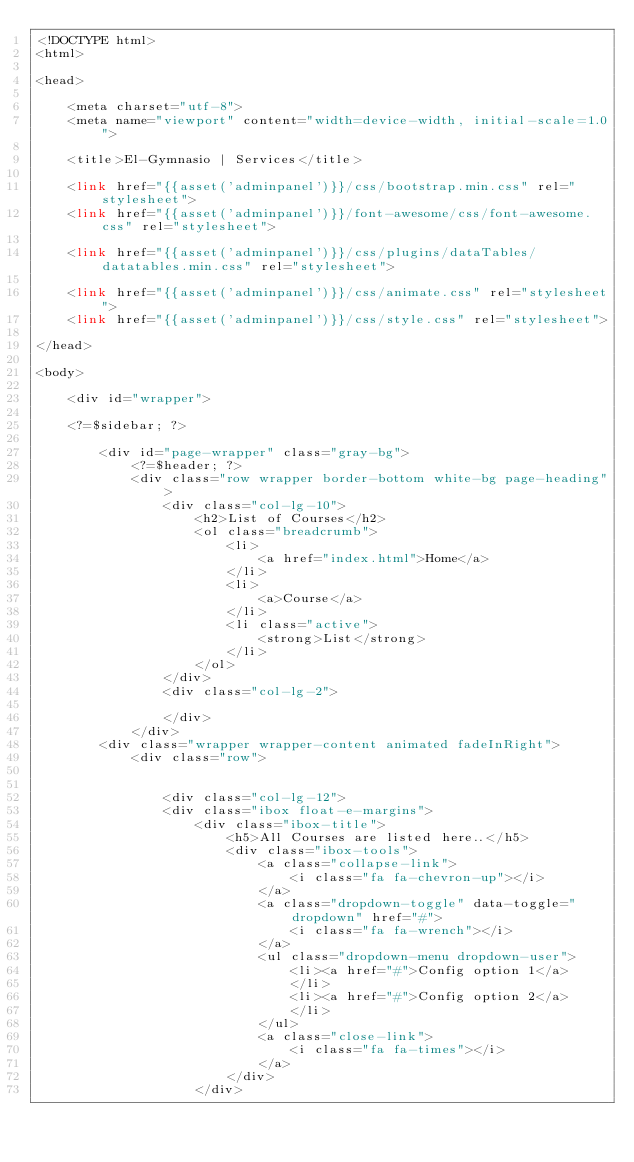Convert code to text. <code><loc_0><loc_0><loc_500><loc_500><_PHP_><!DOCTYPE html>
<html>

<head>

    <meta charset="utf-8">
    <meta name="viewport" content="width=device-width, initial-scale=1.0">

    <title>El-Gymnasio | Services</title>

    <link href="{{asset('adminpanel')}}/css/bootstrap.min.css" rel="stylesheet">
    <link href="{{asset('adminpanel')}}/font-awesome/css/font-awesome.css" rel="stylesheet">

    <link href="{{asset('adminpanel')}}/css/plugins/dataTables/datatables.min.css" rel="stylesheet">

    <link href="{{asset('adminpanel')}}/css/animate.css" rel="stylesheet">
    <link href="{{asset('adminpanel')}}/css/style.css" rel="stylesheet">

</head>

<body>

    <div id="wrapper">

    <?=$sidebar; ?>

        <div id="page-wrapper" class="gray-bg">
            <?=$header; ?>
            <div class="row wrapper border-bottom white-bg page-heading">
                <div class="col-lg-10">
                    <h2>List of Courses</h2>
                    <ol class="breadcrumb">
                        <li>
                            <a href="index.html">Home</a>
                        </li>
                        <li>
                            <a>Course</a>
                        </li>
                        <li class="active">
                            <strong>List</strong>
                        </li>
                    </ol>
                </div>
                <div class="col-lg-2">

                </div>
            </div>
        <div class="wrapper wrapper-content animated fadeInRight">
            <div class="row">


                <div class="col-lg-12">
                <div class="ibox float-e-margins">
                    <div class="ibox-title">
                        <h5>All Courses are listed here..</h5>
                        <div class="ibox-tools">
                            <a class="collapse-link">
                                <i class="fa fa-chevron-up"></i>
                            </a>
                            <a class="dropdown-toggle" data-toggle="dropdown" href="#">
                                <i class="fa fa-wrench"></i>
                            </a>
                            <ul class="dropdown-menu dropdown-user">
                                <li><a href="#">Config option 1</a>
                                </li>
                                <li><a href="#">Config option 2</a>
                                </li>
                            </ul>
                            <a class="close-link">
                                <i class="fa fa-times"></i>
                            </a>
                        </div>
                    </div></code> 